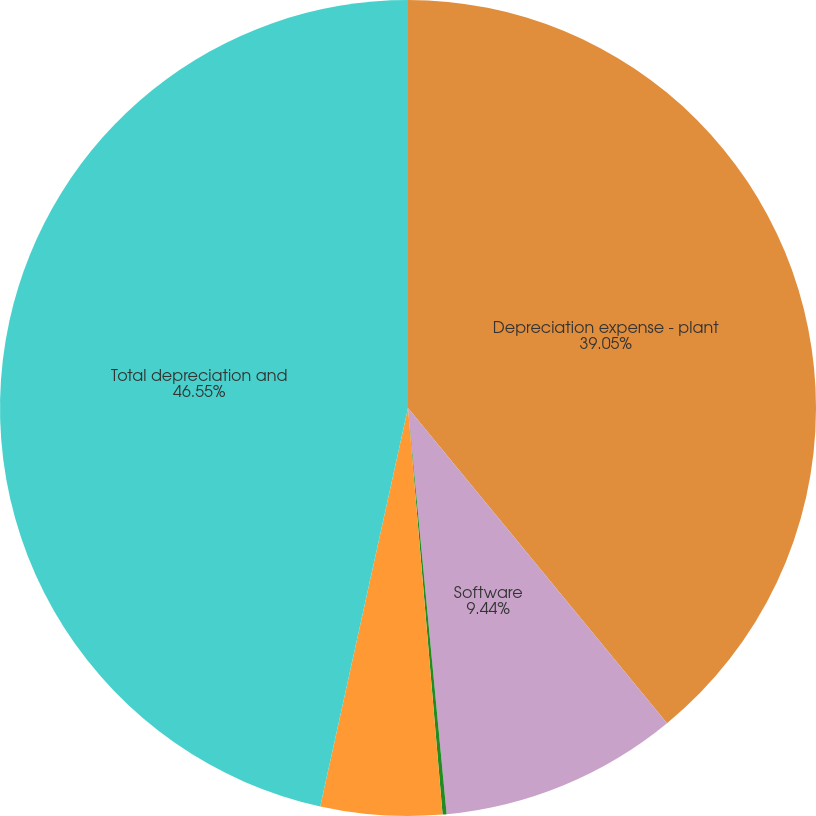Convert chart to OTSL. <chart><loc_0><loc_0><loc_500><loc_500><pie_chart><fcel>Depreciation expense - plant<fcel>Software<fcel>Other intangible assets<fcel>Securitized regulatory assets<fcel>Total depreciation and<nl><fcel>39.05%<fcel>9.44%<fcel>0.16%<fcel>4.8%<fcel>46.55%<nl></chart> 